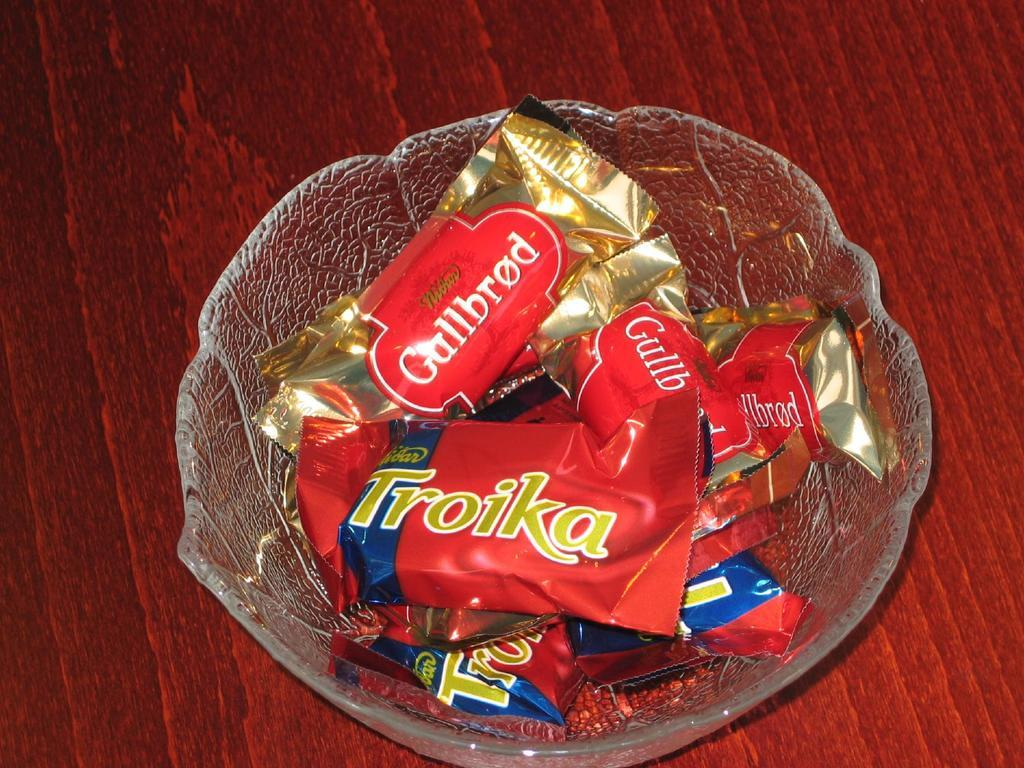What is located in the center of the image? There is a bowl in the center of the image. What is inside the bowl? The bowl contains chocolates. What type of furniture is at the bottom of the image? There is a table at the bottom of the image. How many houses can be seen in the image? There are no houses visible in the image; it only features a bowl of chocolates and a table. What type of insect is buzzing around the chocolates in the image? There is no insect, such as a bee, present in the image. 